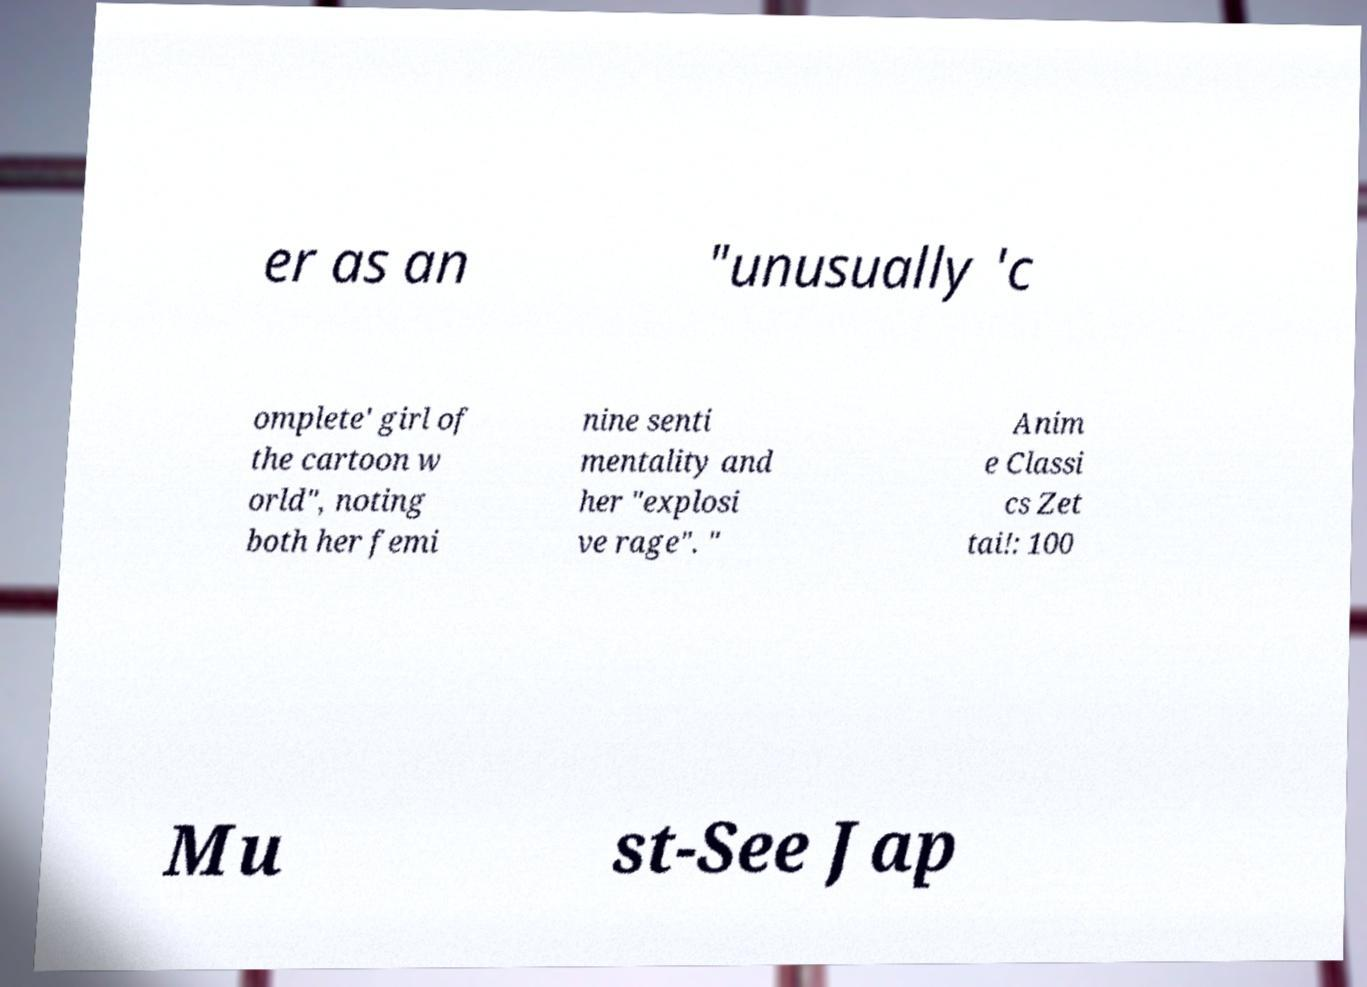Could you assist in decoding the text presented in this image and type it out clearly? er as an "unusually 'c omplete' girl of the cartoon w orld", noting both her femi nine senti mentality and her "explosi ve rage". " Anim e Classi cs Zet tai!: 100 Mu st-See Jap 